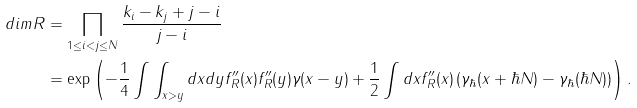Convert formula to latex. <formula><loc_0><loc_0><loc_500><loc_500>d i m R & = \prod _ { 1 \leq i < j \leq N } \frac { k _ { i } - k _ { j } + j - i } { j - i } \\ & = \exp \left ( - \frac { 1 } { 4 } \int \int _ { x > y } d x d y f _ { R } ^ { \prime \prime } ( x ) f _ { R } ^ { \prime \prime } ( y ) \gamma _ { } ( x - y ) + \frac { 1 } { 2 } \int d x f ^ { \prime \prime } _ { R } ( x ) \left ( \gamma _ { \hbar } ( x + \hbar { N } ) - \gamma _ { \hbar } ( \hbar { N } ) \right ) \right ) .</formula> 